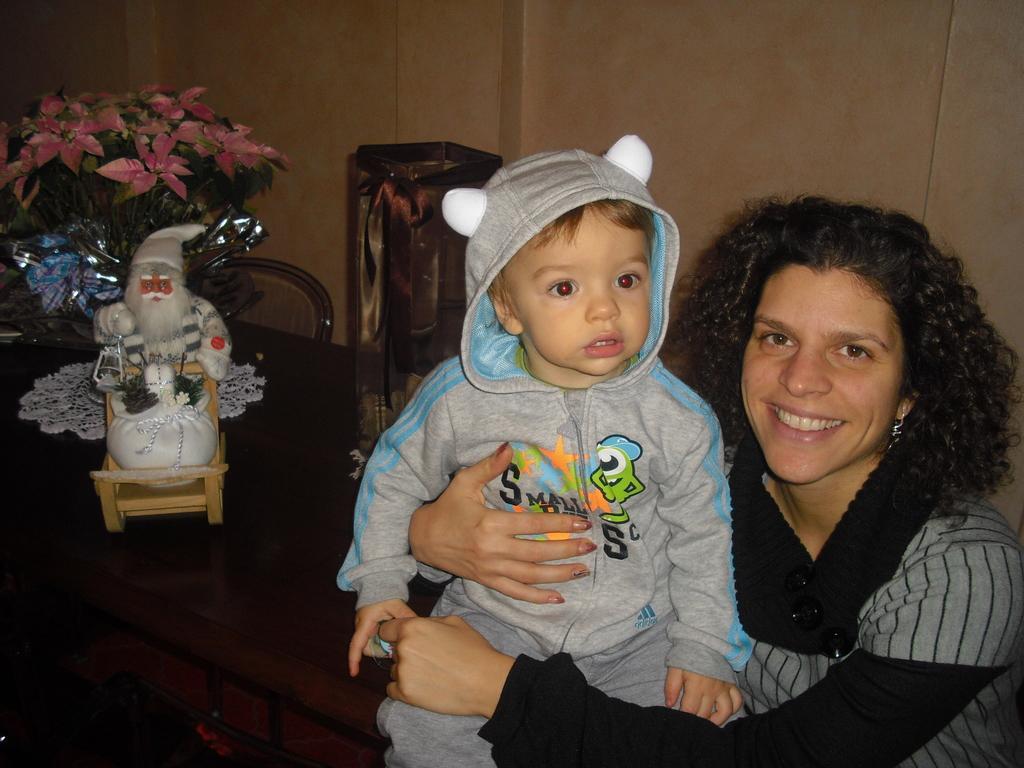Describe this image in one or two sentences. In the center of the image there is a baby. There is a lady. In the background of the image there is a wall. There is a table on which there are objects. 